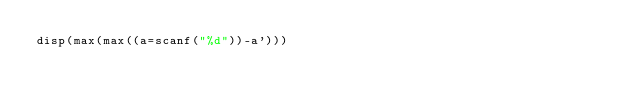Convert code to text. <code><loc_0><loc_0><loc_500><loc_500><_Octave_>disp(max(max((a=scanf("%d"))-a')))</code> 